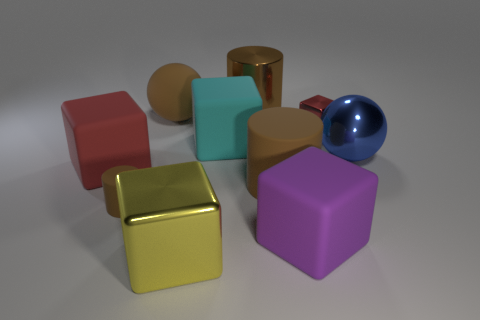Are there any yellow metal cubes of the same size as the yellow shiny thing?
Give a very brief answer. No. Do the small brown matte object and the large brown matte object in front of the big red thing have the same shape?
Your answer should be compact. Yes. There is a large cylinder that is in front of the red cube that is to the left of the brown matte ball; is there a small brown rubber object that is behind it?
Provide a short and direct response. No. The red metallic block is what size?
Provide a short and direct response. Small. How many other objects are the same color as the tiny cube?
Offer a terse response. 1. There is a red object on the left side of the brown sphere; is it the same shape as the big purple matte thing?
Keep it short and to the point. Yes. There is a large shiny object that is the same shape as the red matte thing; what color is it?
Your response must be concise. Yellow. There is another red object that is the same shape as the large red thing; what is its size?
Make the answer very short. Small. What material is the cylinder that is both to the right of the small brown rubber object and in front of the large brown metal cylinder?
Your response must be concise. Rubber. There is a rubber cube left of the tiny matte object; does it have the same color as the small metal cube?
Make the answer very short. Yes. 